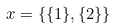Convert formula to latex. <formula><loc_0><loc_0><loc_500><loc_500>x = \{ \{ 1 \} , \{ 2 \} \}</formula> 